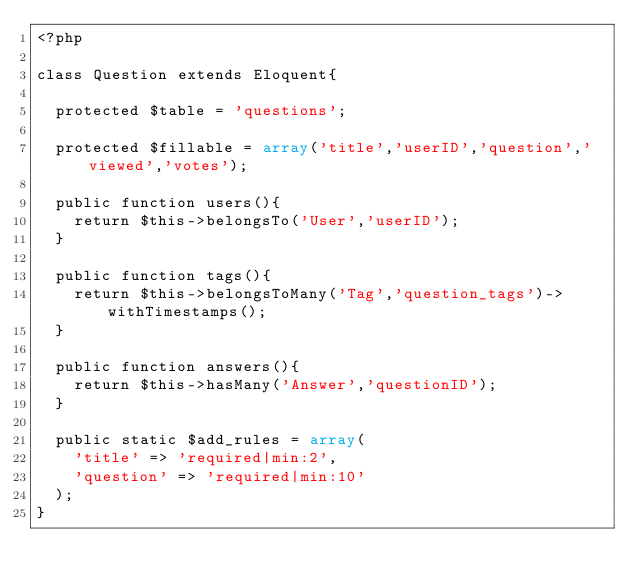<code> <loc_0><loc_0><loc_500><loc_500><_PHP_><?php

class Question extends Eloquent{

	protected $table = 'questions';

	protected $fillable = array('title','userID','question','viewed','votes');

	public function users(){
		return $this->belongsTo('User','userID');
	}

	public function tags(){
		return $this->belongsToMany('Tag','question_tags')->withTimestamps();
	}

	public function answers(){
		return $this->hasMany('Answer','questionID');
	} 

	public static $add_rules = array(
		'title' => 'required|min:2',
		'question' => 'required|min:10'
	);
}</code> 